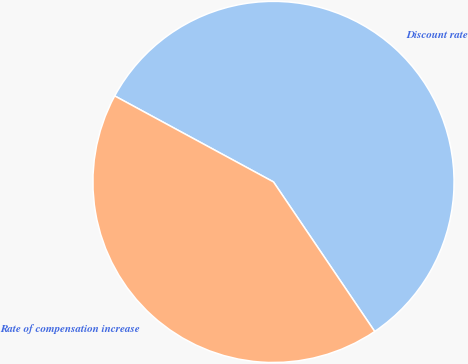<chart> <loc_0><loc_0><loc_500><loc_500><pie_chart><fcel>Discount rate<fcel>Rate of compensation increase<nl><fcel>57.63%<fcel>42.37%<nl></chart> 